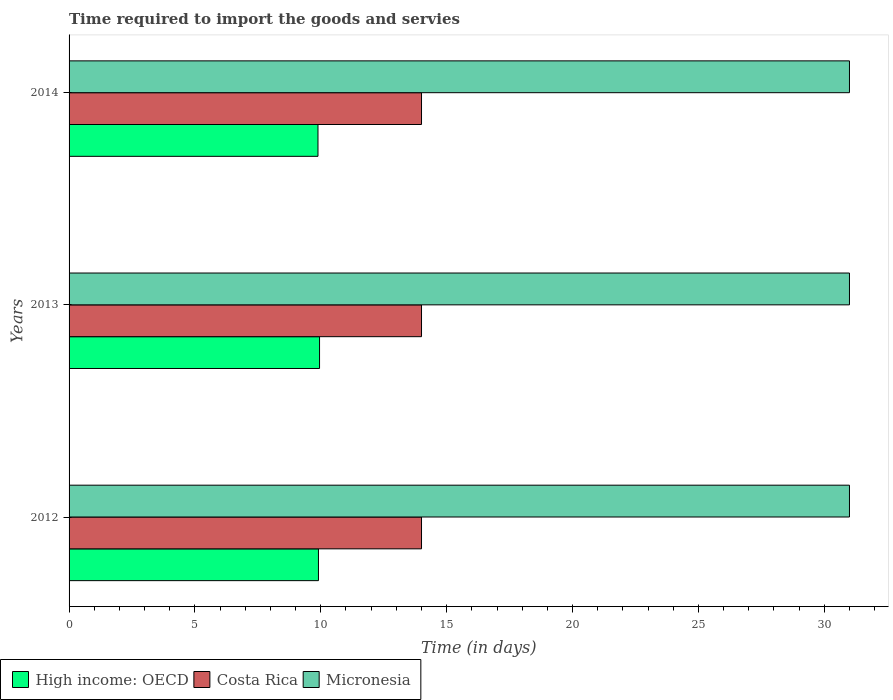How many groups of bars are there?
Give a very brief answer. 3. What is the label of the 2nd group of bars from the top?
Provide a short and direct response. 2013. What is the number of days required to import the goods and services in Costa Rica in 2012?
Ensure brevity in your answer.  14. Across all years, what is the maximum number of days required to import the goods and services in Micronesia?
Offer a terse response. 31. Across all years, what is the minimum number of days required to import the goods and services in Costa Rica?
Provide a short and direct response. 14. In which year was the number of days required to import the goods and services in High income: OECD minimum?
Your answer should be compact. 2014. What is the total number of days required to import the goods and services in High income: OECD in the graph?
Provide a succinct answer. 29.74. What is the difference between the number of days required to import the goods and services in High income: OECD in 2013 and that in 2014?
Make the answer very short. 0.06. What is the difference between the number of days required to import the goods and services in Micronesia in 2013 and the number of days required to import the goods and services in Costa Rica in 2012?
Your answer should be very brief. 17. In the year 2014, what is the difference between the number of days required to import the goods and services in High income: OECD and number of days required to import the goods and services in Costa Rica?
Provide a short and direct response. -4.11. What does the 1st bar from the top in 2014 represents?
Give a very brief answer. Micronesia. What does the 3rd bar from the bottom in 2012 represents?
Provide a succinct answer. Micronesia. Is it the case that in every year, the sum of the number of days required to import the goods and services in High income: OECD and number of days required to import the goods and services in Micronesia is greater than the number of days required to import the goods and services in Costa Rica?
Keep it short and to the point. Yes. Are all the bars in the graph horizontal?
Ensure brevity in your answer.  Yes. Are the values on the major ticks of X-axis written in scientific E-notation?
Keep it short and to the point. No. Does the graph contain any zero values?
Keep it short and to the point. No. How are the legend labels stacked?
Offer a very short reply. Horizontal. What is the title of the graph?
Your answer should be compact. Time required to import the goods and servies. Does "United Arab Emirates" appear as one of the legend labels in the graph?
Offer a terse response. No. What is the label or title of the X-axis?
Provide a short and direct response. Time (in days). What is the Time (in days) in High income: OECD in 2012?
Make the answer very short. 9.91. What is the Time (in days) in Micronesia in 2012?
Make the answer very short. 31. What is the Time (in days) in High income: OECD in 2013?
Your response must be concise. 9.95. What is the Time (in days) in High income: OECD in 2014?
Your answer should be compact. 9.89. What is the Time (in days) in Costa Rica in 2014?
Give a very brief answer. 14. Across all years, what is the maximum Time (in days) of High income: OECD?
Offer a terse response. 9.95. Across all years, what is the maximum Time (in days) in Micronesia?
Give a very brief answer. 31. Across all years, what is the minimum Time (in days) of High income: OECD?
Ensure brevity in your answer.  9.89. Across all years, what is the minimum Time (in days) in Costa Rica?
Offer a very short reply. 14. Across all years, what is the minimum Time (in days) of Micronesia?
Your answer should be very brief. 31. What is the total Time (in days) of High income: OECD in the graph?
Your answer should be compact. 29.74. What is the total Time (in days) in Micronesia in the graph?
Ensure brevity in your answer.  93. What is the difference between the Time (in days) in High income: OECD in 2012 and that in 2013?
Your answer should be very brief. -0.04. What is the difference between the Time (in days) in Costa Rica in 2012 and that in 2013?
Make the answer very short. 0. What is the difference between the Time (in days) in Micronesia in 2012 and that in 2013?
Offer a terse response. 0. What is the difference between the Time (in days) of High income: OECD in 2012 and that in 2014?
Provide a succinct answer. 0.02. What is the difference between the Time (in days) of Costa Rica in 2012 and that in 2014?
Your answer should be very brief. 0. What is the difference between the Time (in days) of High income: OECD in 2013 and that in 2014?
Ensure brevity in your answer.  0.06. What is the difference between the Time (in days) of Costa Rica in 2013 and that in 2014?
Offer a very short reply. 0. What is the difference between the Time (in days) in High income: OECD in 2012 and the Time (in days) in Costa Rica in 2013?
Your answer should be very brief. -4.09. What is the difference between the Time (in days) in High income: OECD in 2012 and the Time (in days) in Micronesia in 2013?
Keep it short and to the point. -21.09. What is the difference between the Time (in days) in High income: OECD in 2012 and the Time (in days) in Costa Rica in 2014?
Offer a terse response. -4.09. What is the difference between the Time (in days) in High income: OECD in 2012 and the Time (in days) in Micronesia in 2014?
Make the answer very short. -21.09. What is the difference between the Time (in days) in Costa Rica in 2012 and the Time (in days) in Micronesia in 2014?
Your answer should be compact. -17. What is the difference between the Time (in days) of High income: OECD in 2013 and the Time (in days) of Costa Rica in 2014?
Your answer should be very brief. -4.05. What is the difference between the Time (in days) in High income: OECD in 2013 and the Time (in days) in Micronesia in 2014?
Provide a succinct answer. -21.05. What is the average Time (in days) of High income: OECD per year?
Ensure brevity in your answer.  9.91. What is the average Time (in days) of Costa Rica per year?
Offer a terse response. 14. What is the average Time (in days) in Micronesia per year?
Offer a very short reply. 31. In the year 2012, what is the difference between the Time (in days) in High income: OECD and Time (in days) in Costa Rica?
Your answer should be compact. -4.09. In the year 2012, what is the difference between the Time (in days) in High income: OECD and Time (in days) in Micronesia?
Offer a terse response. -21.09. In the year 2013, what is the difference between the Time (in days) of High income: OECD and Time (in days) of Costa Rica?
Your answer should be very brief. -4.05. In the year 2013, what is the difference between the Time (in days) in High income: OECD and Time (in days) in Micronesia?
Keep it short and to the point. -21.05. In the year 2014, what is the difference between the Time (in days) of High income: OECD and Time (in days) of Costa Rica?
Make the answer very short. -4.11. In the year 2014, what is the difference between the Time (in days) in High income: OECD and Time (in days) in Micronesia?
Your answer should be very brief. -21.11. What is the ratio of the Time (in days) of Micronesia in 2012 to that in 2013?
Provide a short and direct response. 1. What is the ratio of the Time (in days) in Micronesia in 2012 to that in 2014?
Your response must be concise. 1. What is the ratio of the Time (in days) in High income: OECD in 2013 to that in 2014?
Your answer should be compact. 1.01. What is the ratio of the Time (in days) in Costa Rica in 2013 to that in 2014?
Provide a short and direct response. 1. What is the ratio of the Time (in days) of Micronesia in 2013 to that in 2014?
Make the answer very short. 1. What is the difference between the highest and the second highest Time (in days) in High income: OECD?
Make the answer very short. 0.04. What is the difference between the highest and the second highest Time (in days) of Micronesia?
Your response must be concise. 0. What is the difference between the highest and the lowest Time (in days) in High income: OECD?
Your answer should be compact. 0.06. What is the difference between the highest and the lowest Time (in days) in Micronesia?
Your response must be concise. 0. 